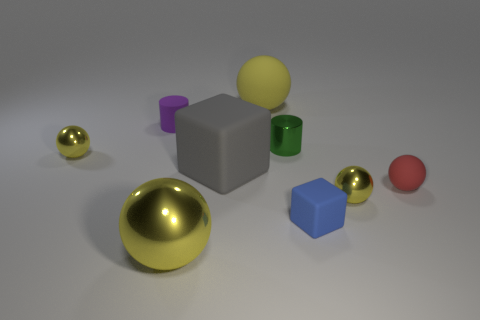There is a metallic sphere that is behind the gray block behind the small blue block; how big is it?
Offer a terse response. Small. There is a gray object that is the same material as the tiny blue thing; what size is it?
Give a very brief answer. Large. How many big objects are green objects or gray metallic cubes?
Ensure brevity in your answer.  0. There is a rubber ball behind the tiny yellow ball to the left of the small metallic thing that is on the right side of the small blue matte block; what size is it?
Offer a very short reply. Large. How many shiny cylinders have the same size as the purple matte thing?
Your answer should be compact. 1. What number of things are either large red shiny blocks or things that are behind the tiny red object?
Make the answer very short. 5. There is a blue matte thing; what shape is it?
Give a very brief answer. Cube. Do the large metallic ball and the small metallic cylinder have the same color?
Your answer should be very brief. No. There is a metal sphere that is the same size as the yellow rubber ball; what is its color?
Provide a succinct answer. Yellow. How many red objects are large metal spheres or cylinders?
Provide a short and direct response. 0. 